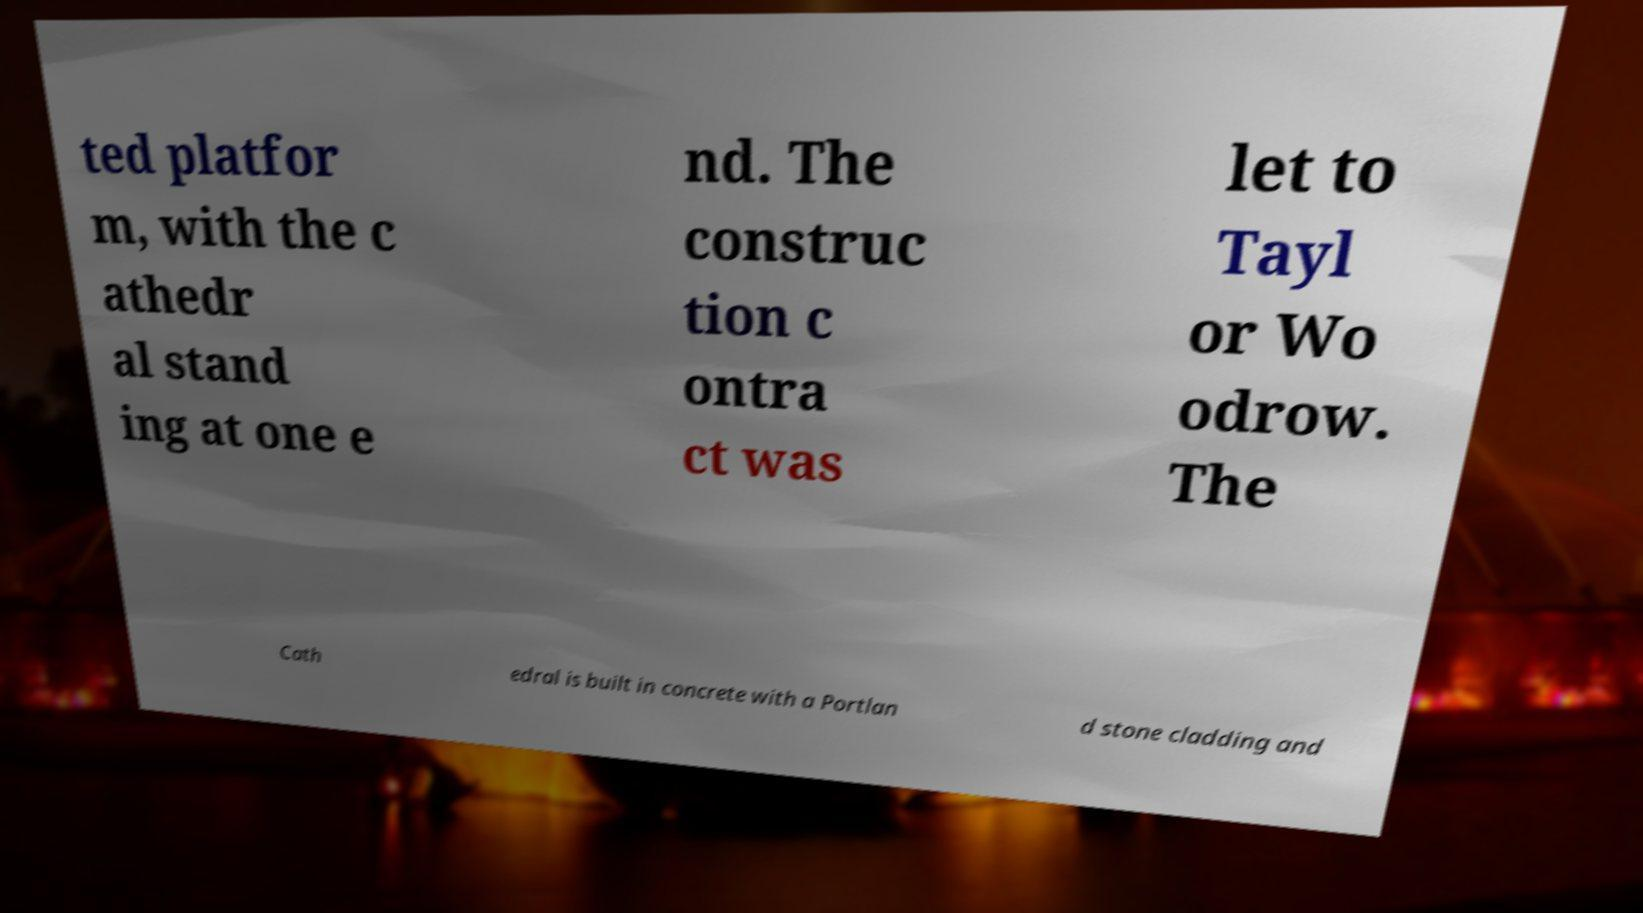Please read and relay the text visible in this image. What does it say? ted platfor m, with the c athedr al stand ing at one e nd. The construc tion c ontra ct was let to Tayl or Wo odrow. The Cath edral is built in concrete with a Portlan d stone cladding and 